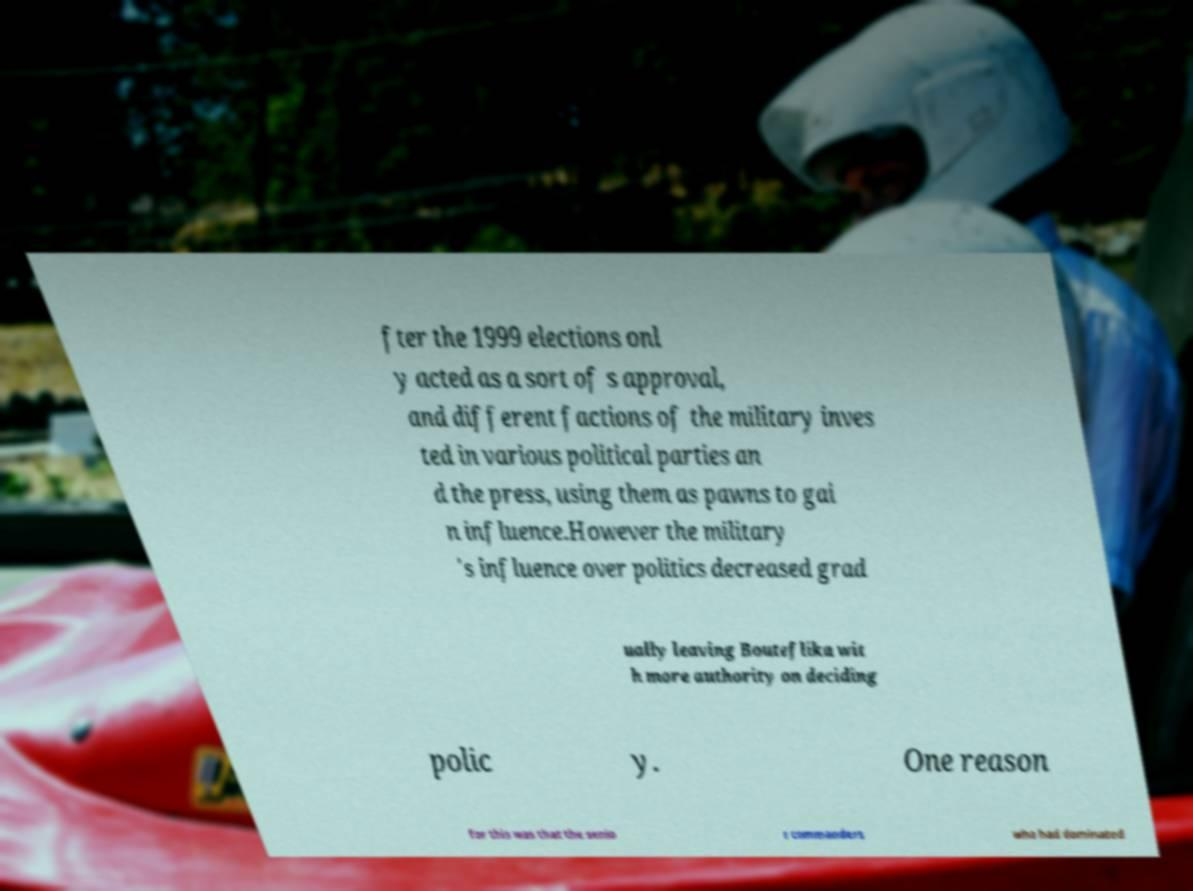Please identify and transcribe the text found in this image. fter the 1999 elections onl y acted as a sort of s approval, and different factions of the military inves ted in various political parties an d the press, using them as pawns to gai n influence.However the military 's influence over politics decreased grad ually leaving Bouteflika wit h more authority on deciding polic y. One reason for this was that the senio r commanders who had dominated 